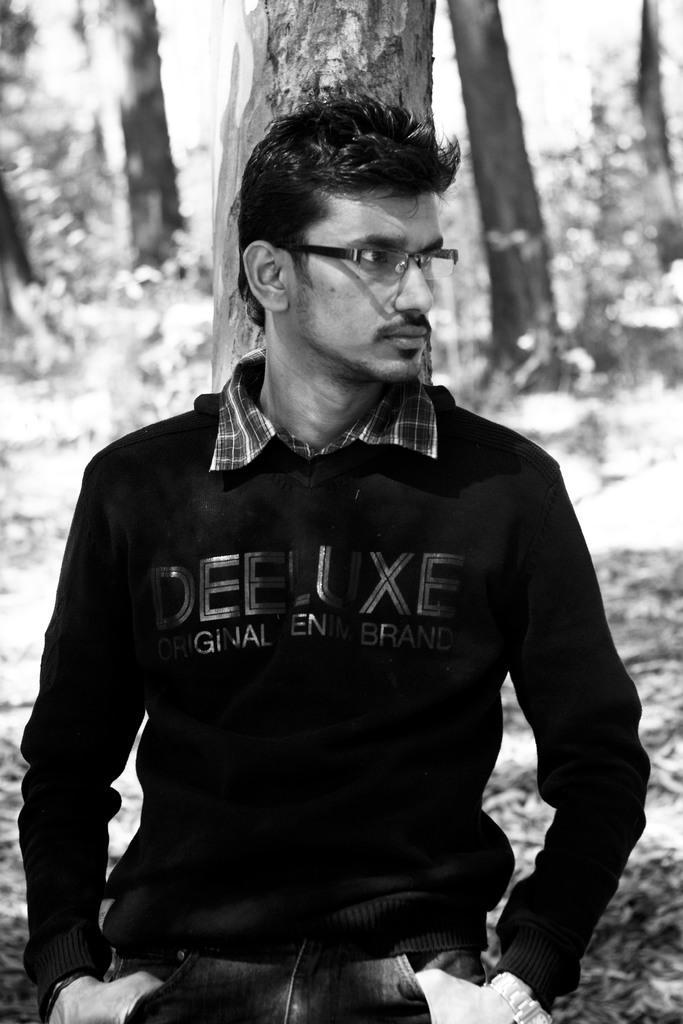In one or two sentences, can you explain what this image depicts? It is the black and white image in which there is a man standing by laying on the tree. 